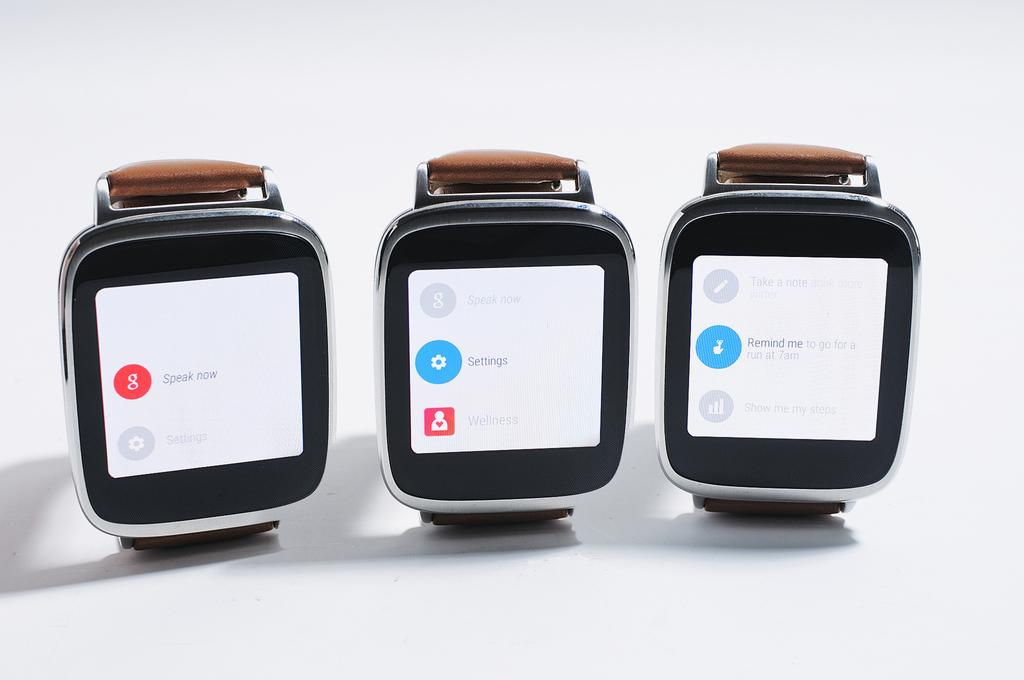<image>
Write a terse but informative summary of the picture. Three smart watches showing options like "Speak now". 